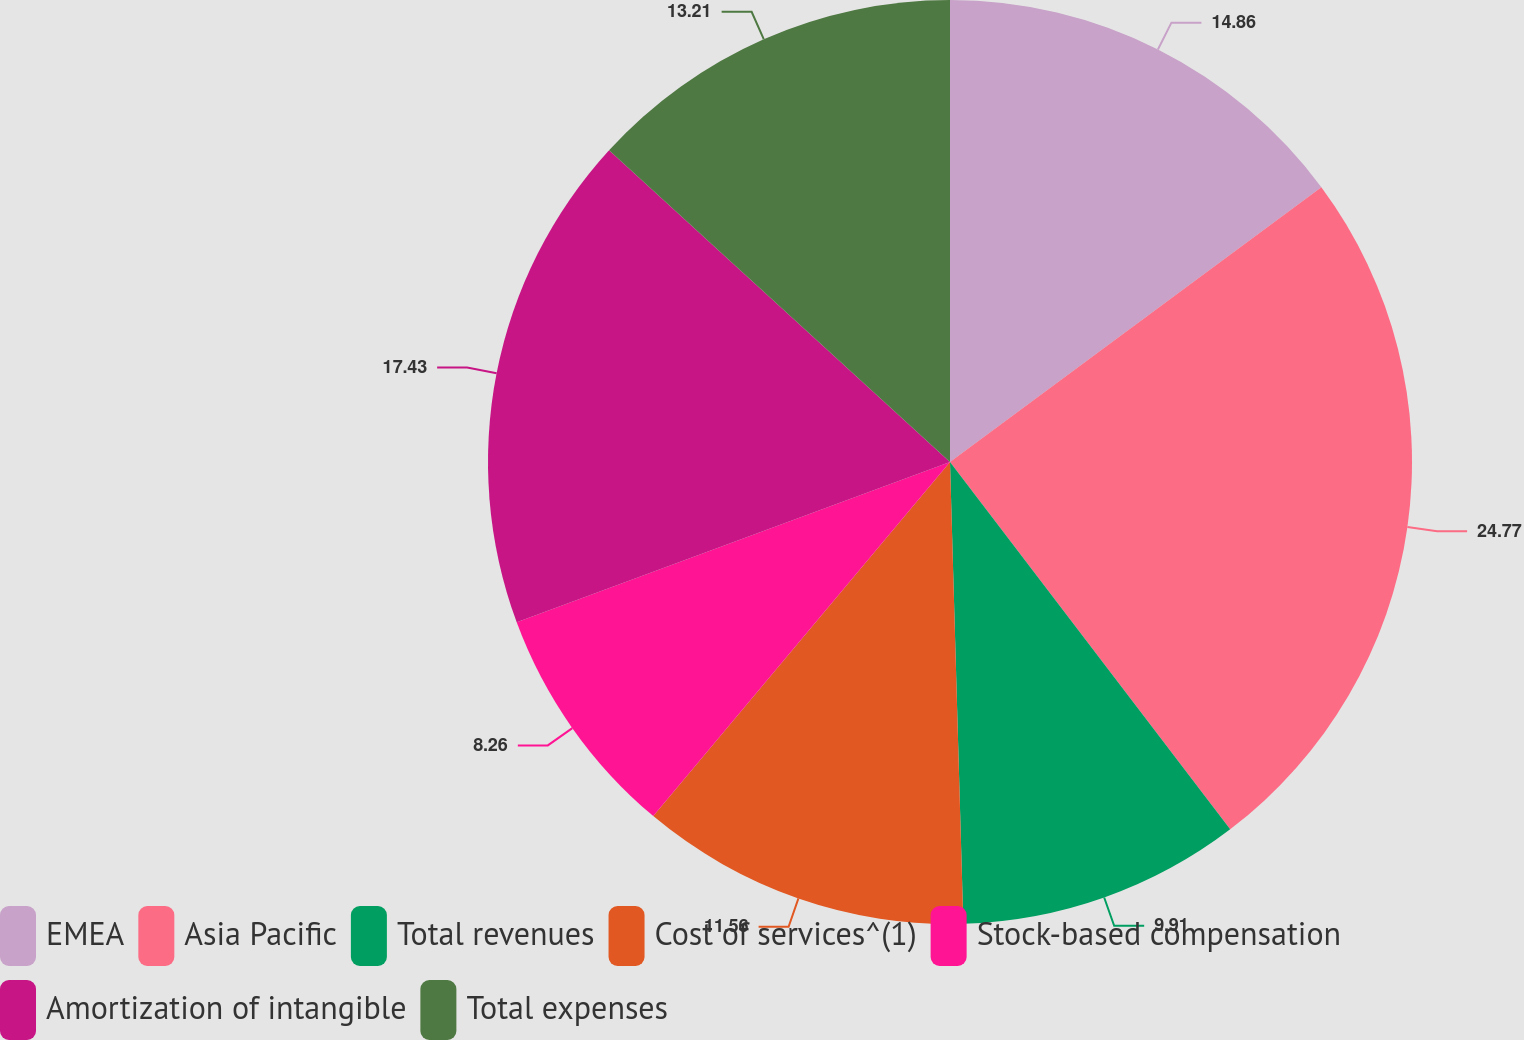<chart> <loc_0><loc_0><loc_500><loc_500><pie_chart><fcel>EMEA<fcel>Asia Pacific<fcel>Total revenues<fcel>Cost of services^(1)<fcel>Stock-based compensation<fcel>Amortization of intangible<fcel>Total expenses<nl><fcel>14.86%<fcel>24.77%<fcel>9.91%<fcel>11.56%<fcel>8.26%<fcel>17.43%<fcel>13.21%<nl></chart> 